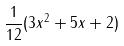<formula> <loc_0><loc_0><loc_500><loc_500>\frac { 1 } { 1 2 } ( 3 x ^ { 2 } + 5 x + 2 )</formula> 